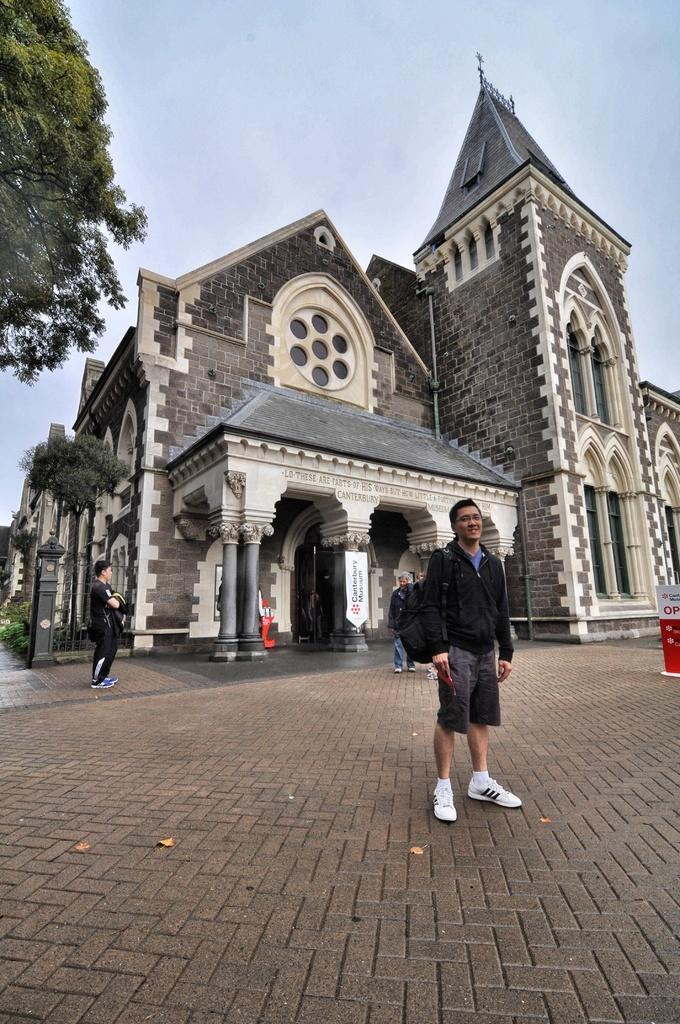What are the people in the image doing? The people in the image are standing on the ground. What structure can be seen in the image? There is a building in the image. What type of vegetation is present in the image? There are trees in the image. What decorative items can be seen in the image? There are banners in the image. What other objects are present in the image? There are other objects in the image, but their specific details are not mentioned in the facts. What is visible in the background of the image? The sky is visible in the background of the image. What type of stem can be seen growing from the banners in the image? There is no stem growing from the banners in the image. How much sugar is present in the image? There is no mention of sugar in the image. 